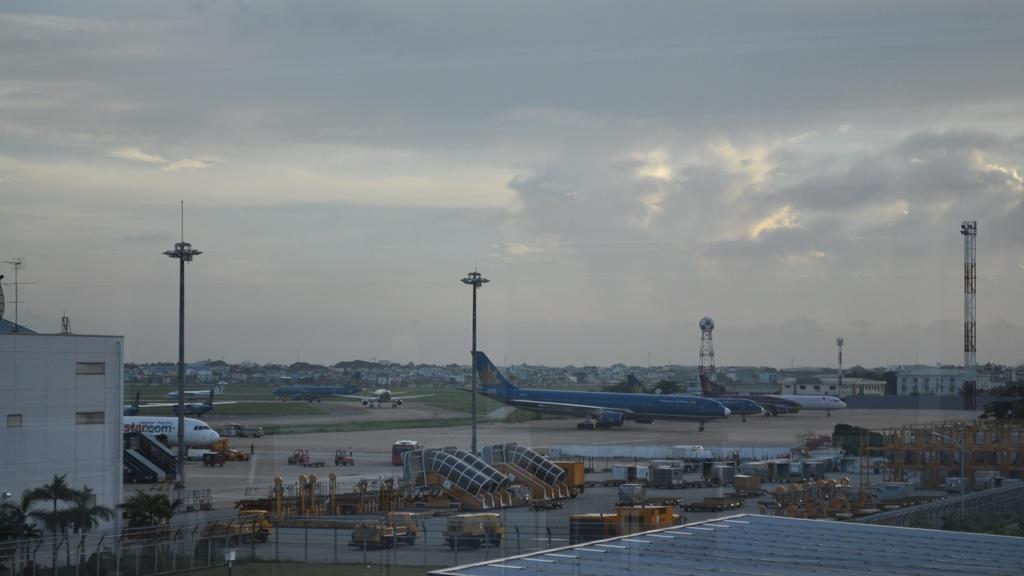Can you describe this image briefly? In this image at the bottom we can see trees and building on the left side, roof, vehicles on the road, objects, rods, poles, metal objects and fence. In the background we can see planes and vehicles on the road, towers, buildings, grass on the ground and clouds in the sky. 